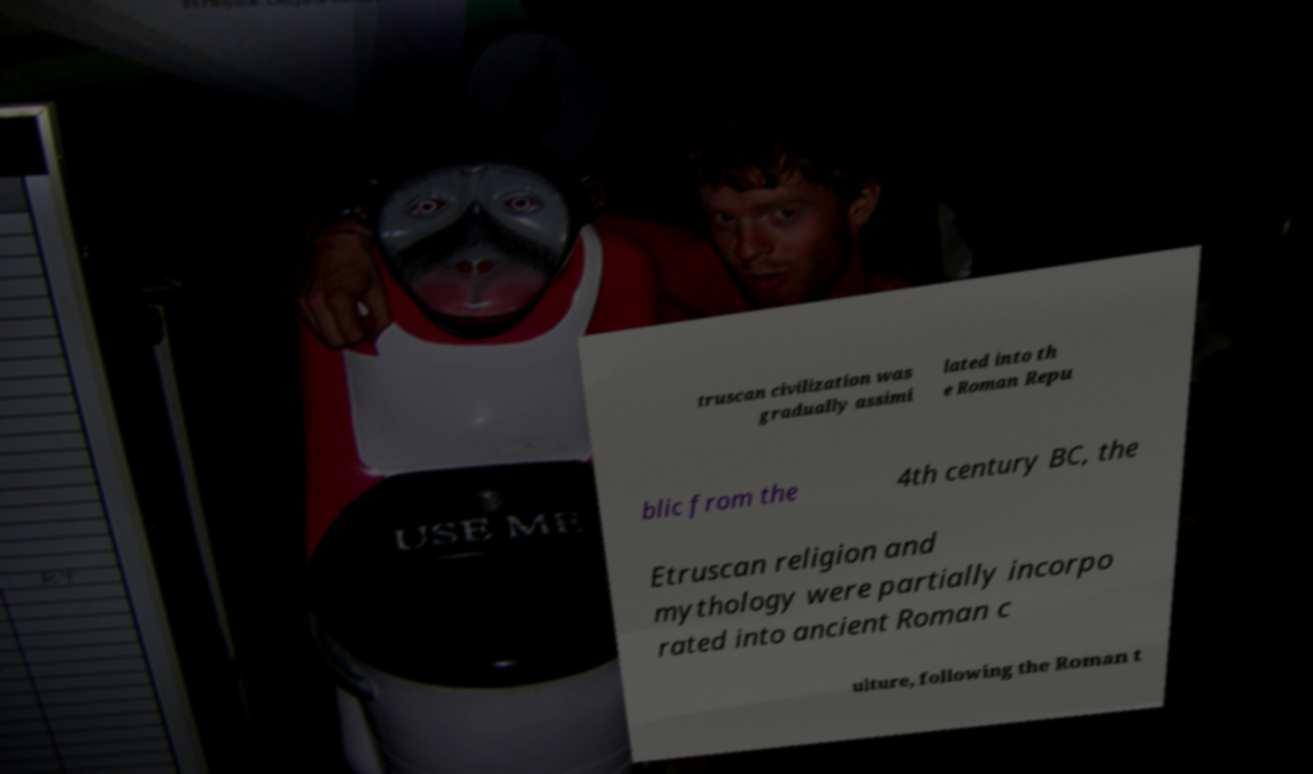Could you assist in decoding the text presented in this image and type it out clearly? truscan civilization was gradually assimi lated into th e Roman Repu blic from the 4th century BC, the Etruscan religion and mythology were partially incorpo rated into ancient Roman c ulture, following the Roman t 